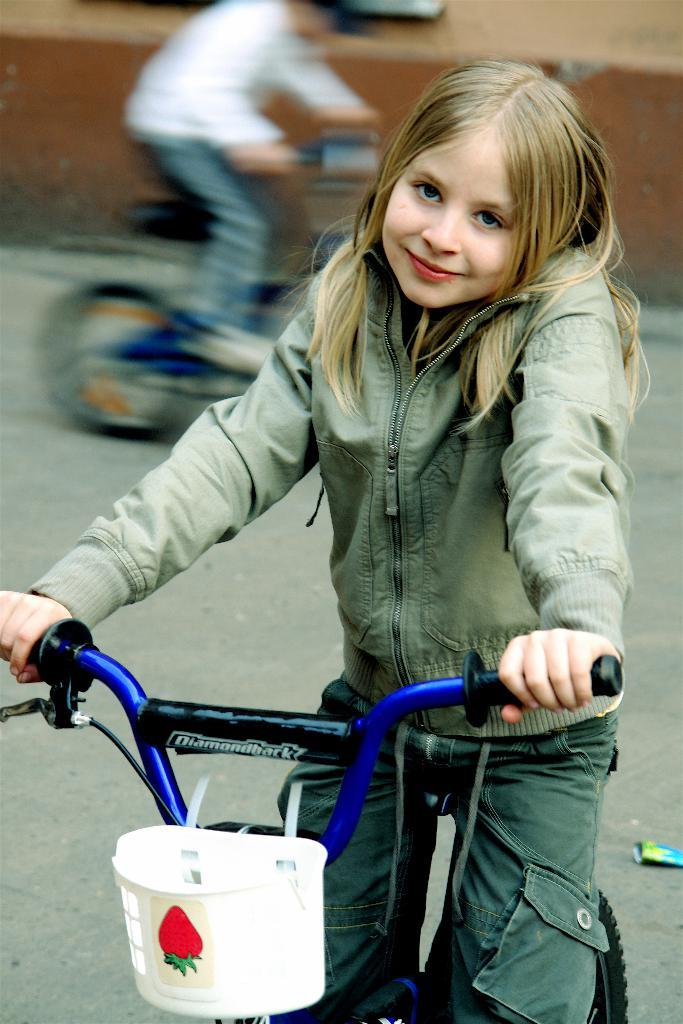What is the main subject of the image? There is a girl on a bicycle in the image. What can be seen in the background of the image? There is a road in the image. Are there any other people in the image? Yes, there is another person on a bicycle in the image. What is the purpose of the wall in the image? The wall in the image could be serving as a boundary or a backdrop. What type of bread is the girl eating while riding the bicycle in the image? There is no bread present in the image; the girl is riding a bicycle. 